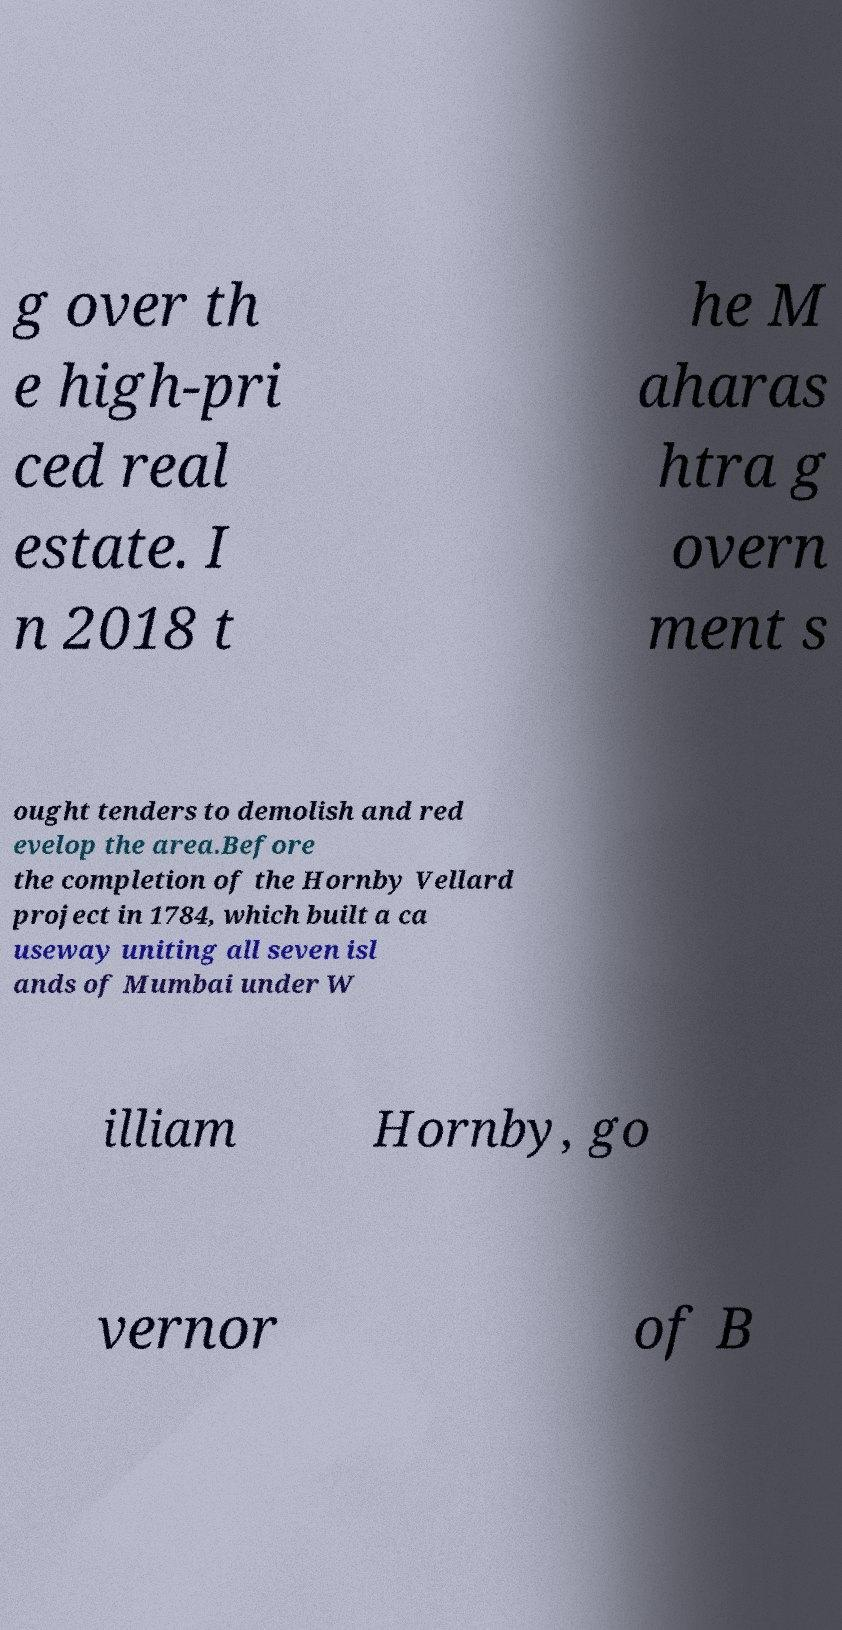Could you assist in decoding the text presented in this image and type it out clearly? g over th e high-pri ced real estate. I n 2018 t he M aharas htra g overn ment s ought tenders to demolish and red evelop the area.Before the completion of the Hornby Vellard project in 1784, which built a ca useway uniting all seven isl ands of Mumbai under W illiam Hornby, go vernor of B 